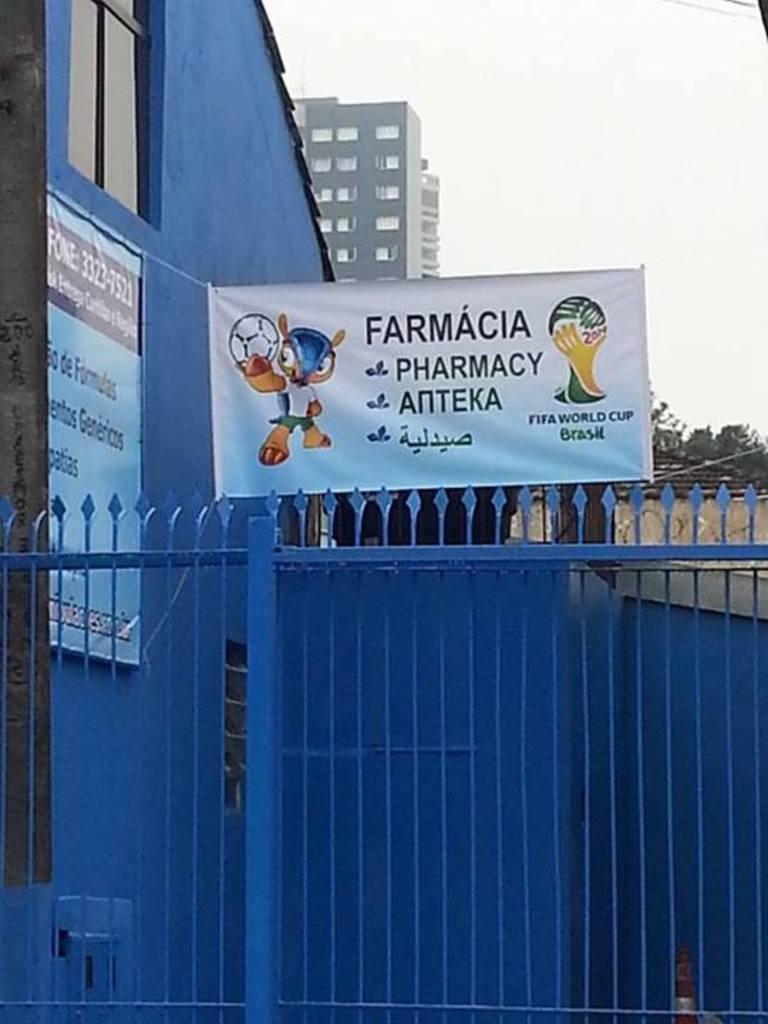<image>
Offer a succinct explanation of the picture presented. A banner over a fence reads Farmacia Pharmacy Anteka. 